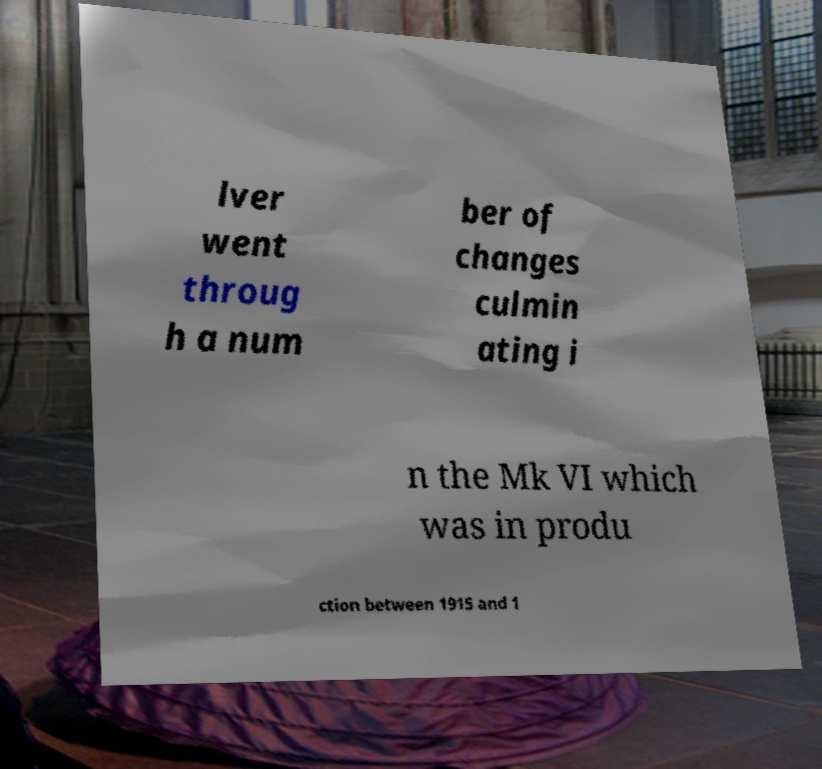Can you accurately transcribe the text from the provided image for me? lver went throug h a num ber of changes culmin ating i n the Mk VI which was in produ ction between 1915 and 1 